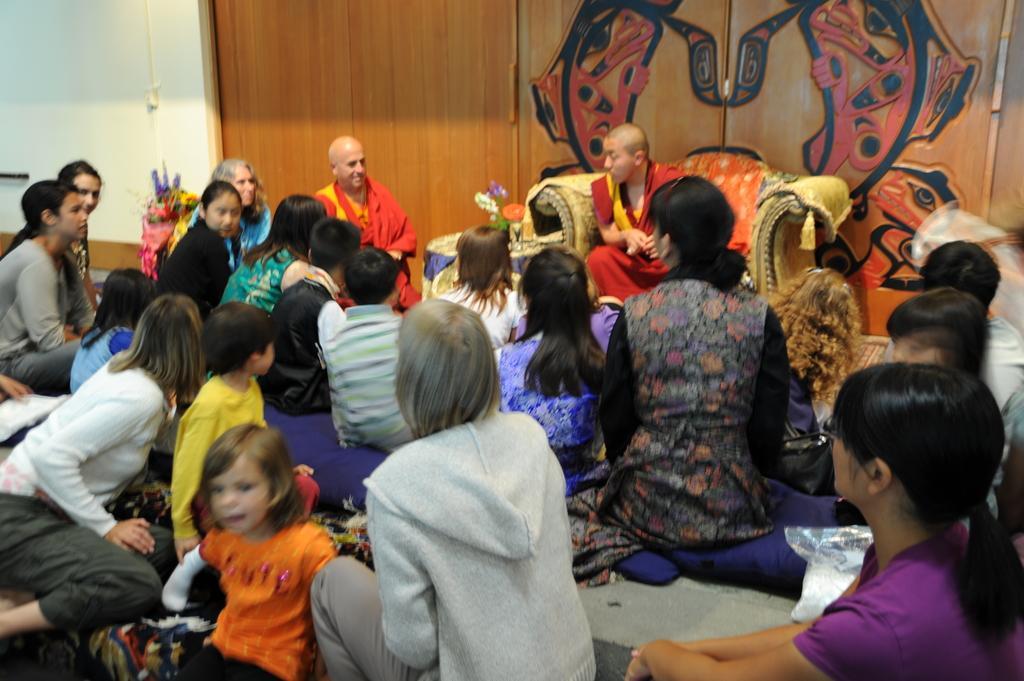Describe this image in one or two sentences. In this picture I can see few people seated and a man seated on the chair and I can see doors on the back. 